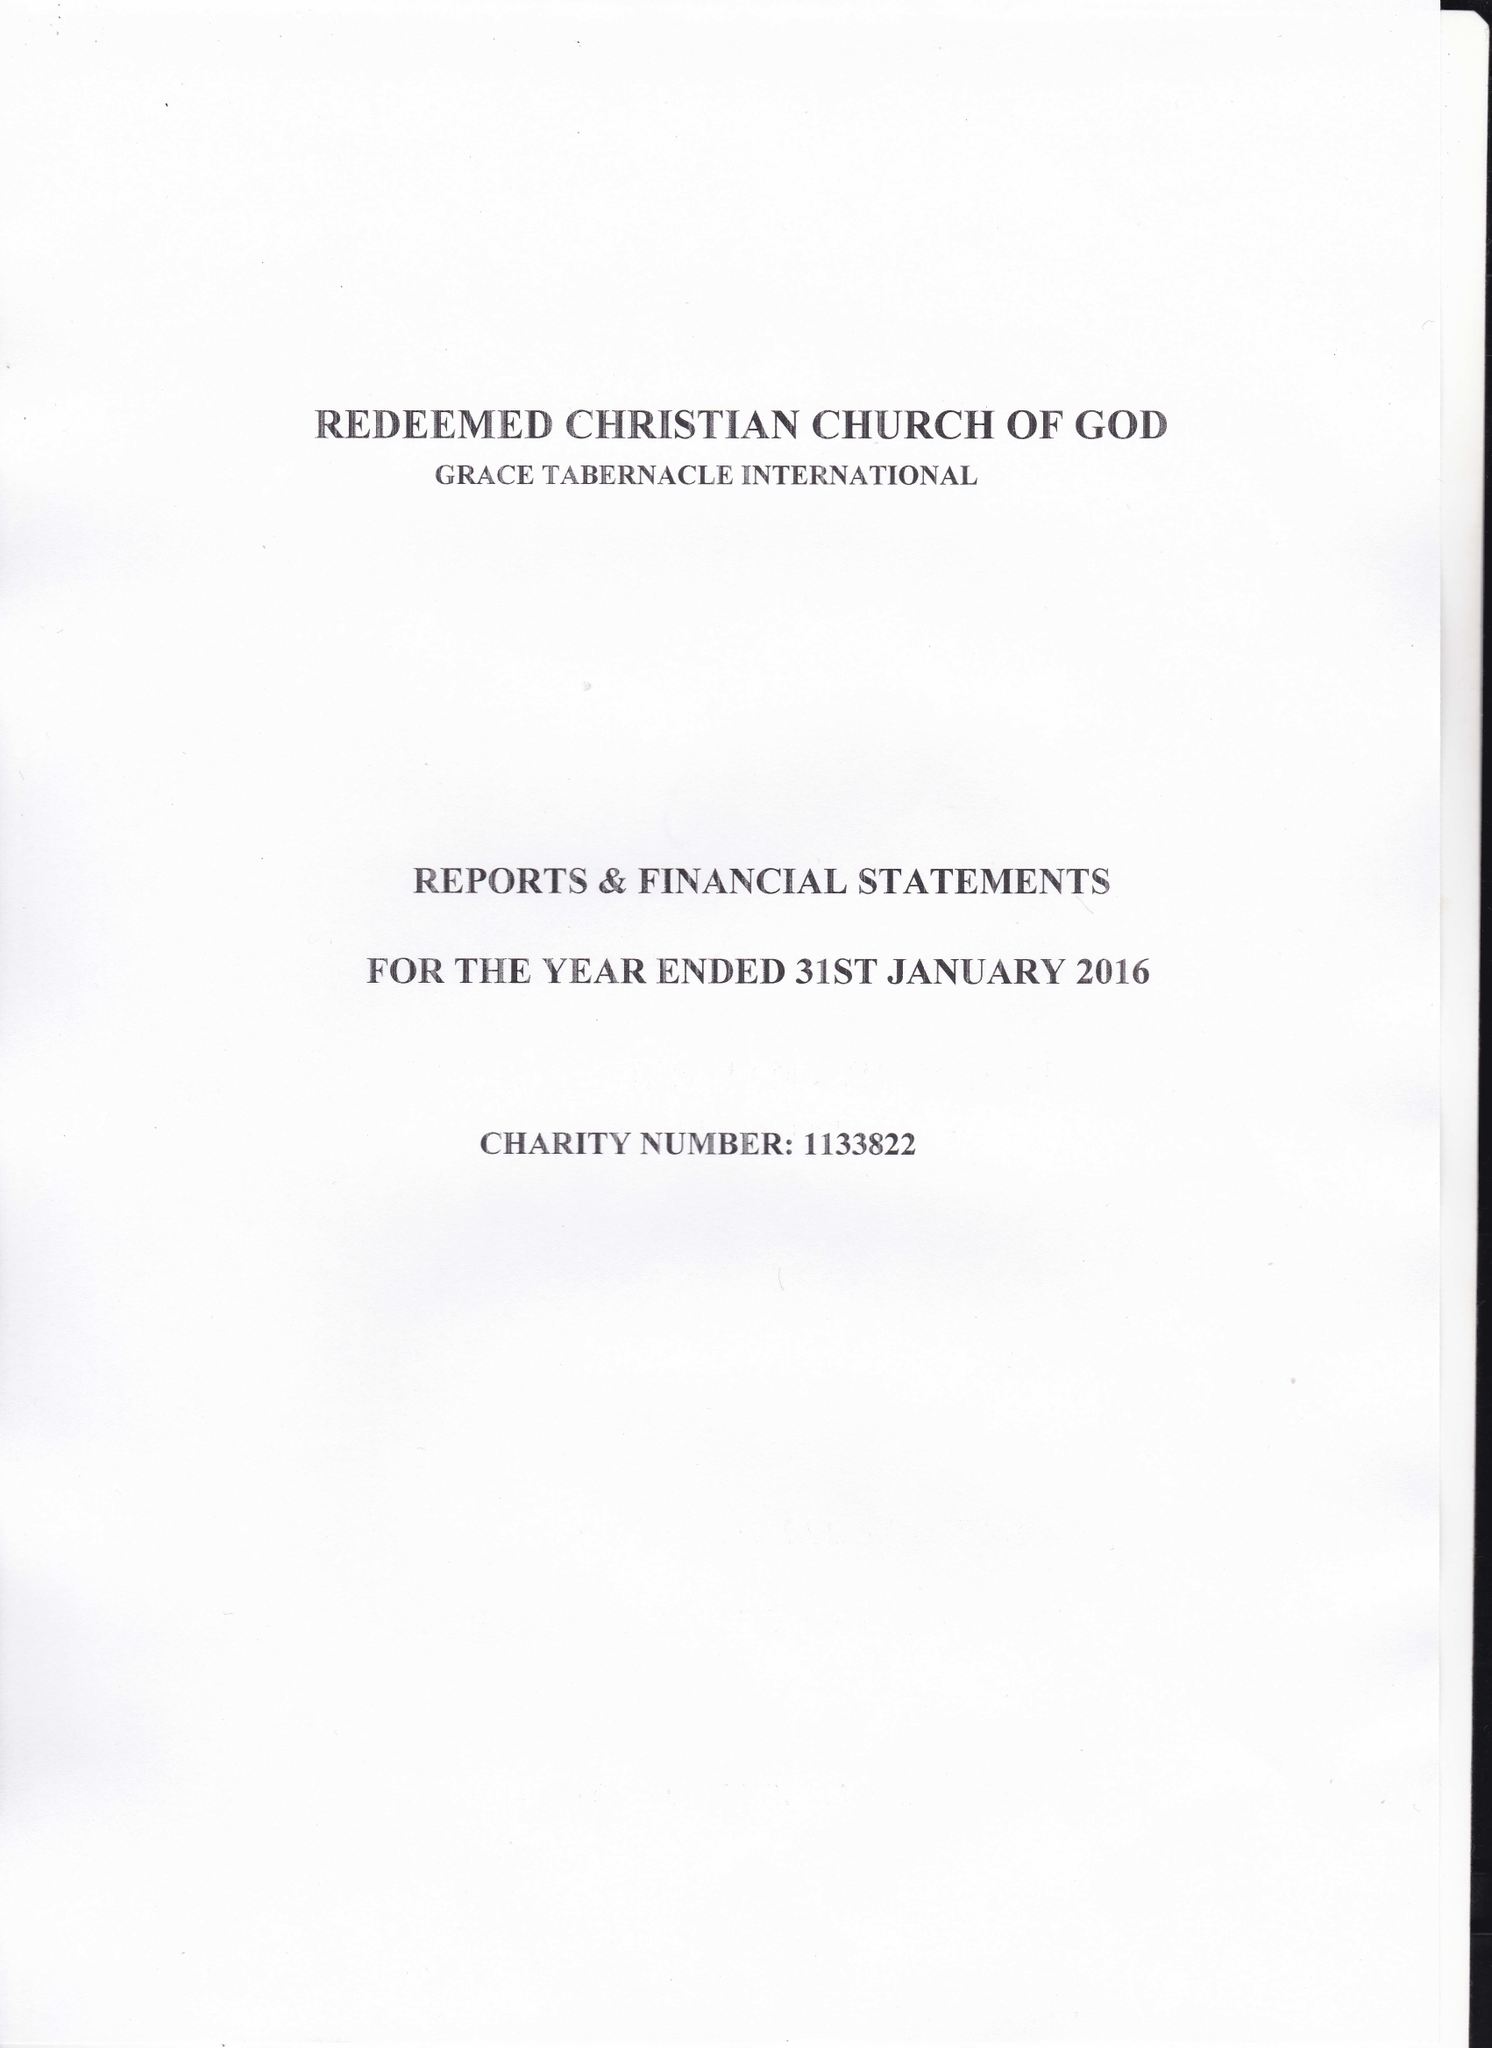What is the value for the address__post_town?
Answer the question using a single word or phrase. CROYDON 